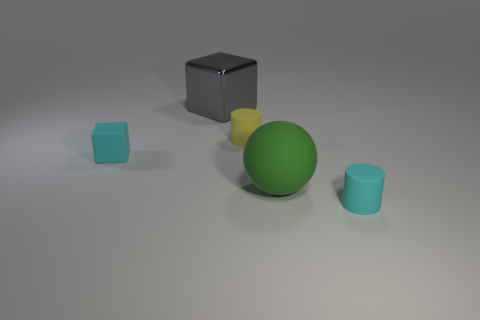Add 2 tiny cubes. How many objects exist? 7 Subtract all spheres. How many objects are left? 4 Subtract all small rubber things. Subtract all cyan matte balls. How many objects are left? 2 Add 5 yellow rubber cylinders. How many yellow rubber cylinders are left? 6 Add 1 rubber cylinders. How many rubber cylinders exist? 3 Subtract 0 brown cylinders. How many objects are left? 5 